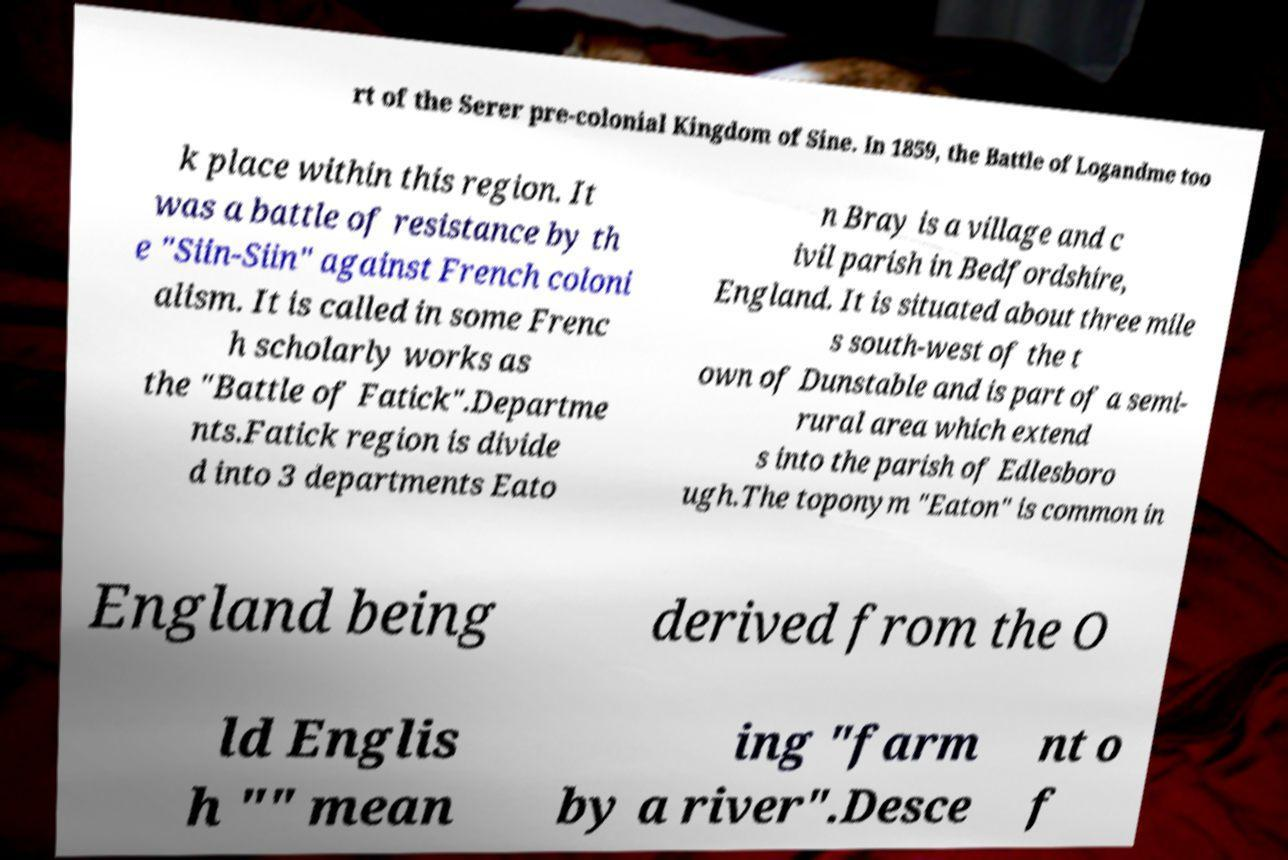Please read and relay the text visible in this image. What does it say? rt of the Serer pre-colonial Kingdom of Sine. In 1859, the Battle of Logandme too k place within this region. It was a battle of resistance by th e "Siin-Siin" against French coloni alism. It is called in some Frenc h scholarly works as the "Battle of Fatick".Departme nts.Fatick region is divide d into 3 departments Eato n Bray is a village and c ivil parish in Bedfordshire, England. It is situated about three mile s south-west of the t own of Dunstable and is part of a semi- rural area which extend s into the parish of Edlesboro ugh.The toponym "Eaton" is common in England being derived from the O ld Englis h "" mean ing "farm by a river".Desce nt o f 